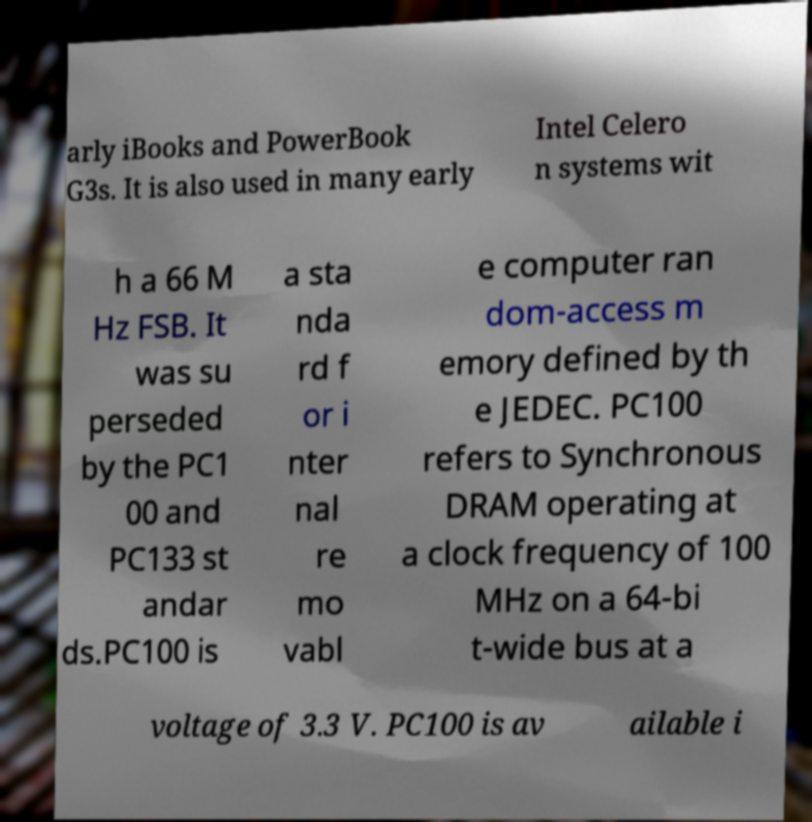For documentation purposes, I need the text within this image transcribed. Could you provide that? arly iBooks and PowerBook G3s. It is also used in many early Intel Celero n systems wit h a 66 M Hz FSB. It was su perseded by the PC1 00 and PC133 st andar ds.PC100 is a sta nda rd f or i nter nal re mo vabl e computer ran dom-access m emory defined by th e JEDEC. PC100 refers to Synchronous DRAM operating at a clock frequency of 100 MHz on a 64-bi t-wide bus at a voltage of 3.3 V. PC100 is av ailable i 